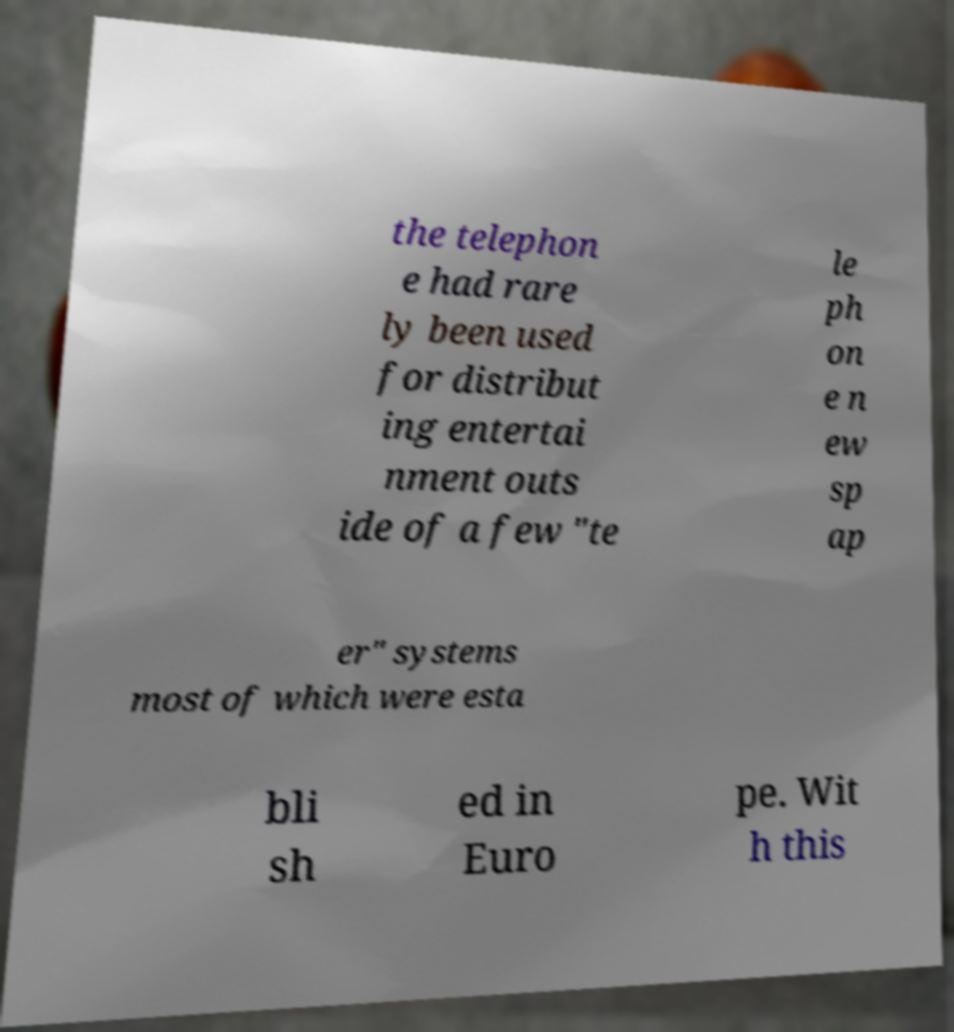Can you accurately transcribe the text from the provided image for me? the telephon e had rare ly been used for distribut ing entertai nment outs ide of a few "te le ph on e n ew sp ap er" systems most of which were esta bli sh ed in Euro pe. Wit h this 